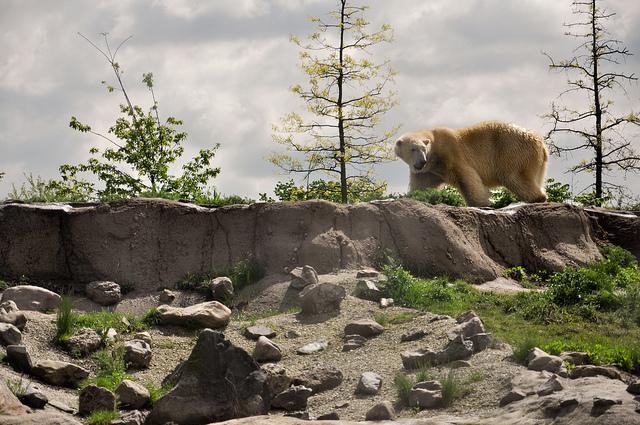What types of bears are these?
Short answer required. Polar. Is the bear trying to find food?
Give a very brief answer. Yes. Is it a sunny day?
Be succinct. No. Are the trees old?
Give a very brief answer. No. 